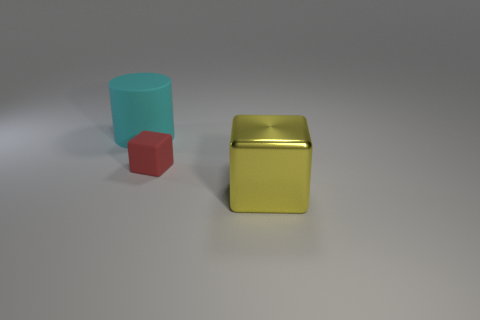Add 1 large blue blocks. How many objects exist? 4 Subtract all cylinders. How many objects are left? 2 Subtract 1 cyan cylinders. How many objects are left? 2 Subtract all large yellow matte objects. Subtract all yellow shiny cubes. How many objects are left? 2 Add 3 large shiny things. How many large shiny things are left? 4 Add 2 large matte cylinders. How many large matte cylinders exist? 3 